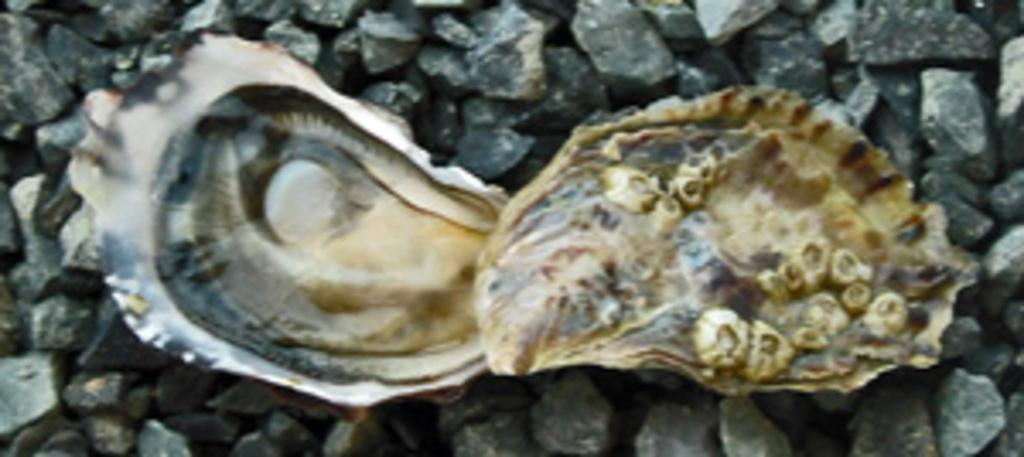What object can be seen in the image? There is a shell in the image. What colors are present on the shell? The shell has black and yellow colors. On what surface is the shell placed? The shell is placed on concrete stones. What type of ticket is visible in the image? There is no ticket present in the image; it features a shell on concrete stones. What kind of metal object can be seen near the shell in the image? There is no metal object present in the image; it only features a shell on concrete stones. 